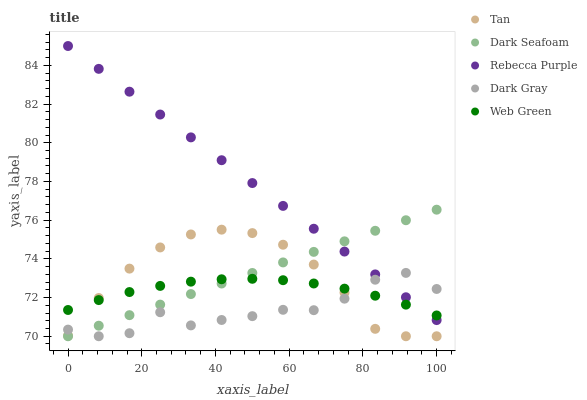Does Dark Gray have the minimum area under the curve?
Answer yes or no. Yes. Does Rebecca Purple have the maximum area under the curve?
Answer yes or no. Yes. Does Tan have the minimum area under the curve?
Answer yes or no. No. Does Tan have the maximum area under the curve?
Answer yes or no. No. Is Dark Seafoam the smoothest?
Answer yes or no. Yes. Is Dark Gray the roughest?
Answer yes or no. Yes. Is Tan the smoothest?
Answer yes or no. No. Is Tan the roughest?
Answer yes or no. No. Does Dark Gray have the lowest value?
Answer yes or no. Yes. Does Web Green have the lowest value?
Answer yes or no. No. Does Rebecca Purple have the highest value?
Answer yes or no. Yes. Does Tan have the highest value?
Answer yes or no. No. Is Tan less than Rebecca Purple?
Answer yes or no. Yes. Is Rebecca Purple greater than Tan?
Answer yes or no. Yes. Does Rebecca Purple intersect Web Green?
Answer yes or no. Yes. Is Rebecca Purple less than Web Green?
Answer yes or no. No. Is Rebecca Purple greater than Web Green?
Answer yes or no. No. Does Tan intersect Rebecca Purple?
Answer yes or no. No. 